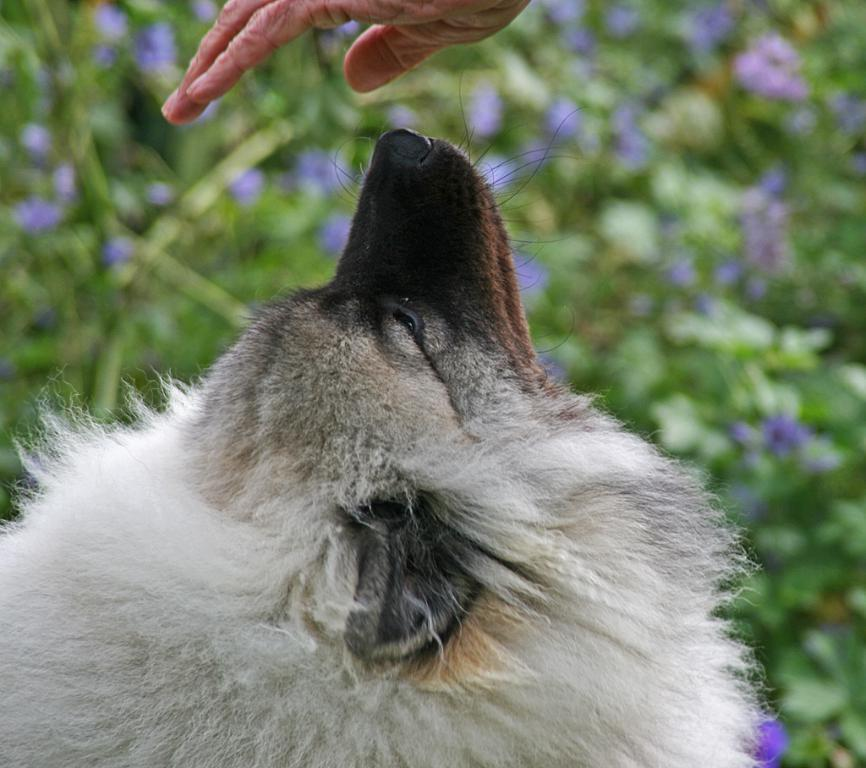What animal is present at the bottom of the image? There is a dog at the bottom of the image. What part of a person can be seen at the top of the image? There is a person's hand at the top of the image. What type of vegetation is visible in the background of the image? There are plants in the background of the image. What type of curtain can be seen in the image? There is no curtain present in the image. What is the dog's role in the ongoing war in the image? There is no war or any indication of conflict in the image, and the dog's role cannot be determined. 